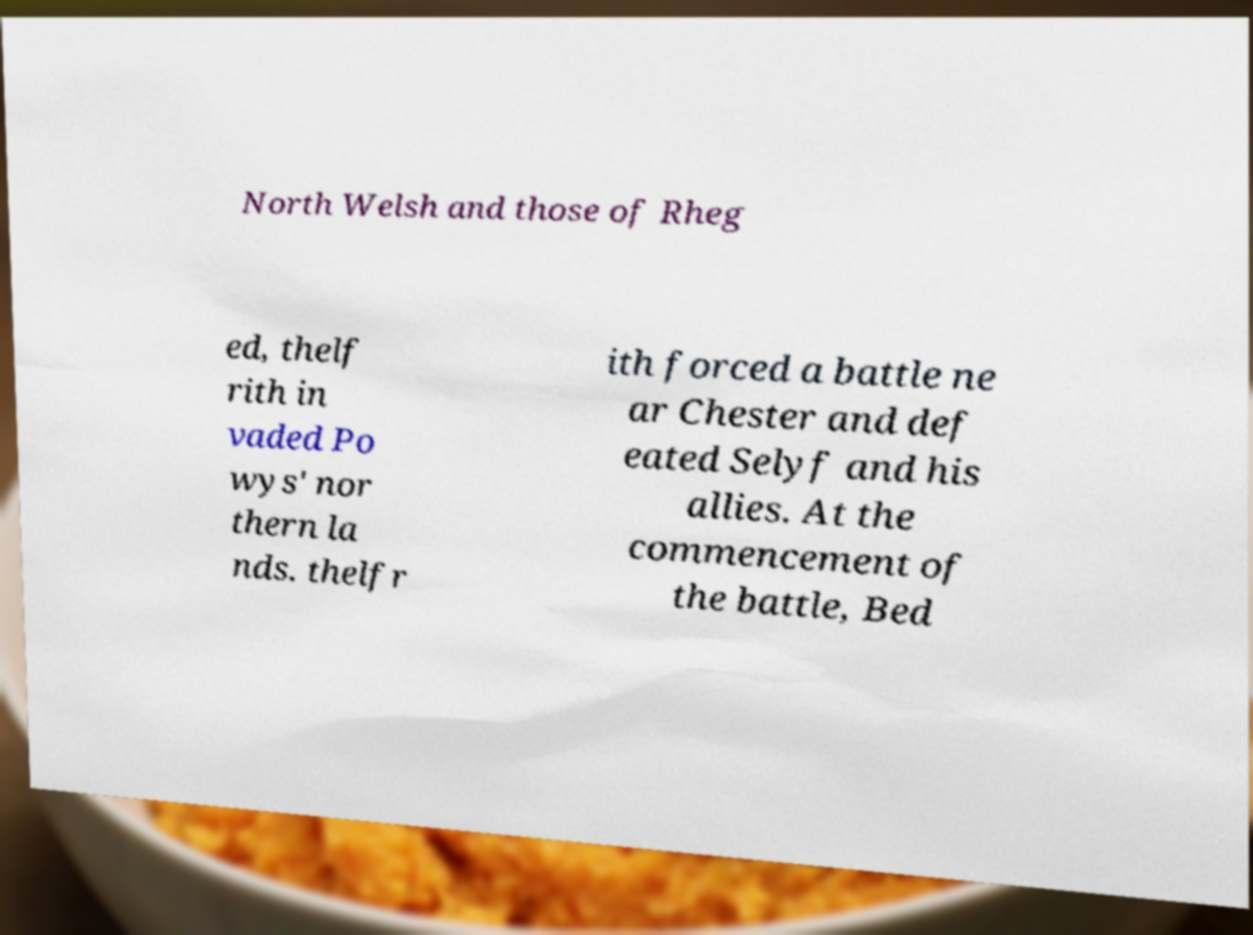Can you read and provide the text displayed in the image?This photo seems to have some interesting text. Can you extract and type it out for me? North Welsh and those of Rheg ed, thelf rith in vaded Po wys' nor thern la nds. thelfr ith forced a battle ne ar Chester and def eated Selyf and his allies. At the commencement of the battle, Bed 